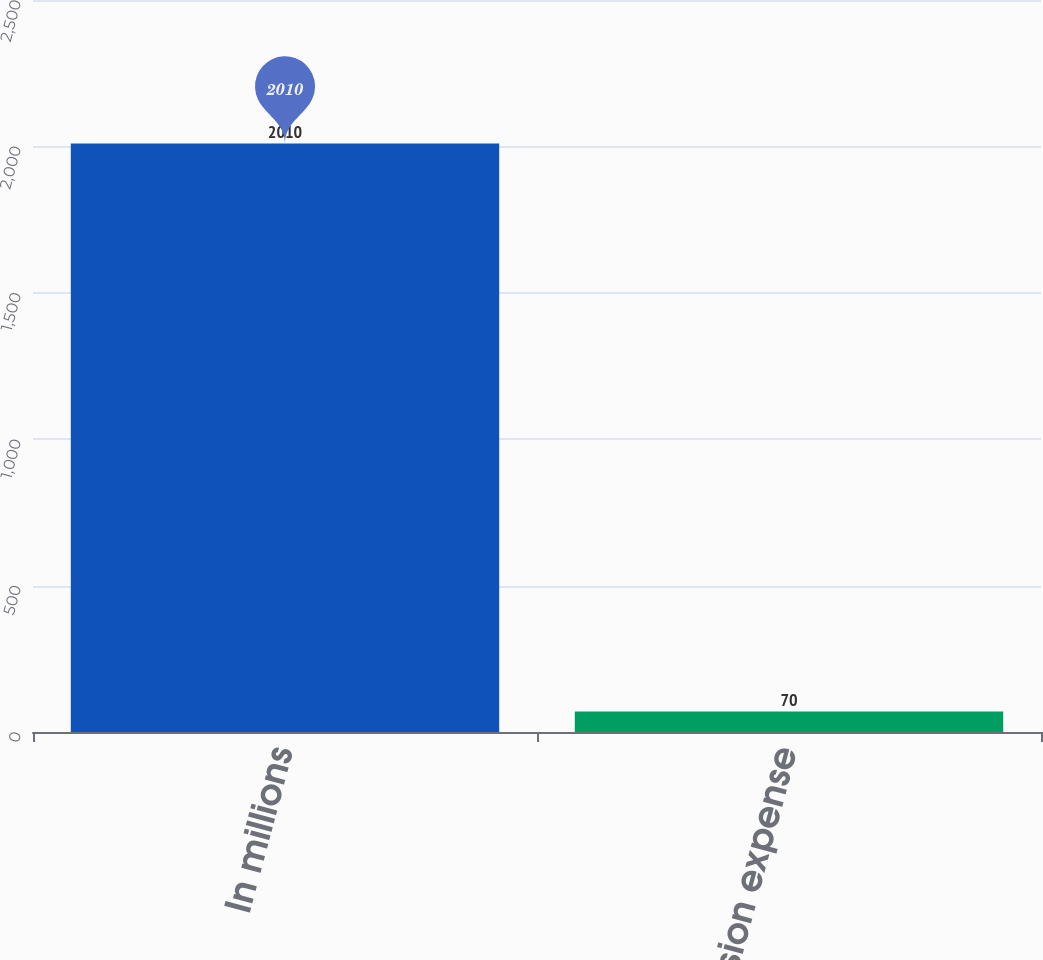Convert chart to OTSL. <chart><loc_0><loc_0><loc_500><loc_500><bar_chart><fcel>In millions<fcel>Pension expense<nl><fcel>2010<fcel>70<nl></chart> 